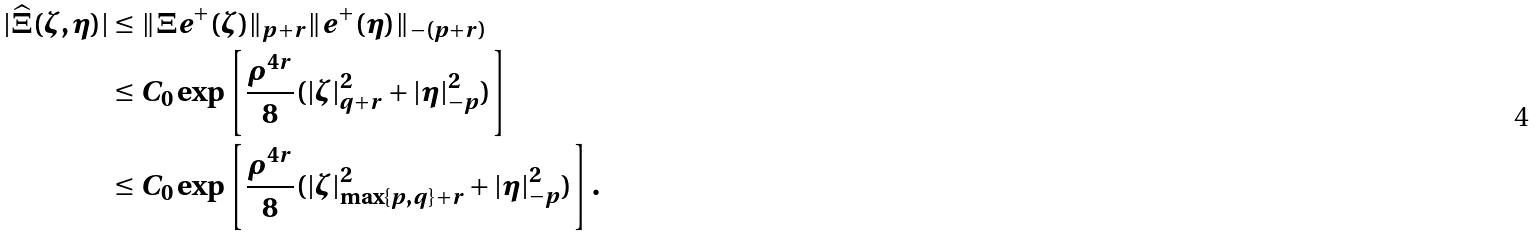<formula> <loc_0><loc_0><loc_500><loc_500>| \widehat { \Xi } ( \zeta , \eta ) | & \leq \| \Xi e ^ { + } ( \zeta ) \| _ { p + r } \| e ^ { + } ( \eta ) \| _ { - ( p + r ) } \\ & \leq C _ { 0 } \exp \left [ \frac { \rho ^ { 4 r } } { 8 } ( | \zeta | _ { q + r } ^ { 2 } + | \eta | _ { - p } ^ { 2 } ) \right ] \\ & \leq C _ { 0 } \exp \left [ \frac { \rho ^ { 4 r } } { 8 } ( | \zeta | _ { \max \{ p , q \} + r } ^ { 2 } + | \eta | _ { - p } ^ { 2 } ) \right ] .</formula> 